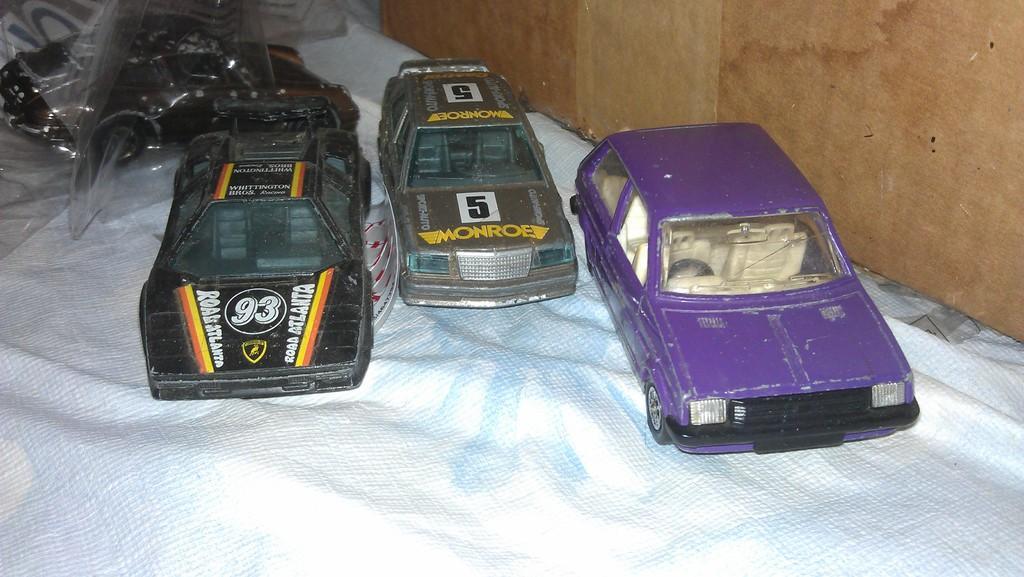Can you describe this image briefly? In this image there are three cars one beside the other on the mat. On the right side there is a wall. In the background there is a cover on the toy car. 